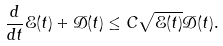<formula> <loc_0><loc_0><loc_500><loc_500>\frac { d } { d t } \mathcal { E } ( t ) + \mathcal { D } ( t ) \leq C \sqrt { \mathcal { E } ( t ) } \mathcal { D } ( t ) .</formula> 